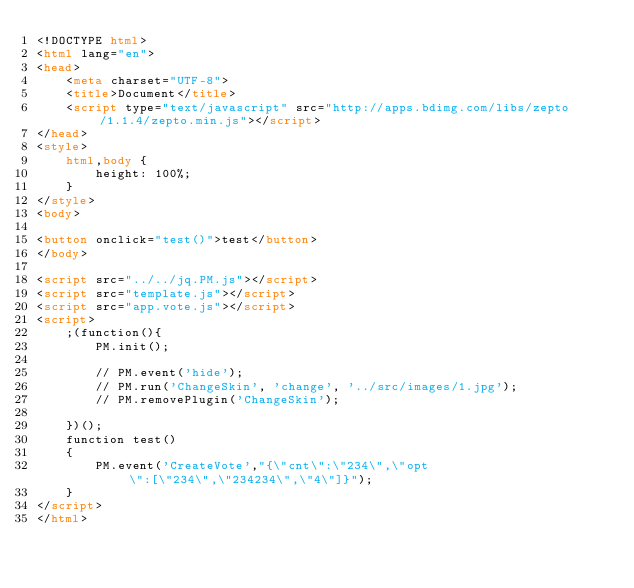Convert code to text. <code><loc_0><loc_0><loc_500><loc_500><_HTML_><!DOCTYPE html>
<html lang="en">
<head>
    <meta charset="UTF-8">
    <title>Document</title>
    <script type="text/javascript" src="http://apps.bdimg.com/libs/zepto/1.1.4/zepto.min.js"></script>
</head>
<style>
    html,body {
        height: 100%;
    }
</style>
<body>

<button onclick="test()">test</button>
</body>

<script src="../../jq.PM.js"></script>
<script src="template.js"></script>
<script src="app.vote.js"></script>
<script>
    ;(function(){
        PM.init();

        // PM.event('hide');
        // PM.run('ChangeSkin', 'change', '../src/images/1.jpg');
        // PM.removePlugin('ChangeSkin');

    })();
    function test()
    {
        PM.event('CreateVote',"{\"cnt\":\"234\",\"opt\":[\"234\",\"234234\",\"4\"]}");
    }
</script>
</html></code> 